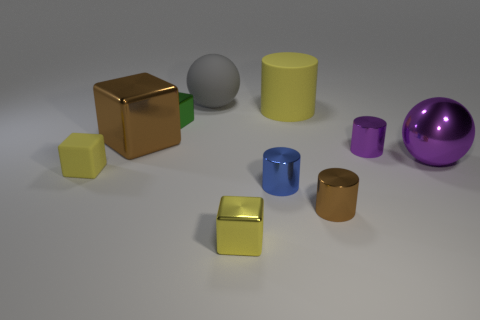The yellow object that is the same material as the big cylinder is what shape? The yellow object sharing the same material as the larger cylinder appears to be a smaller cube. 